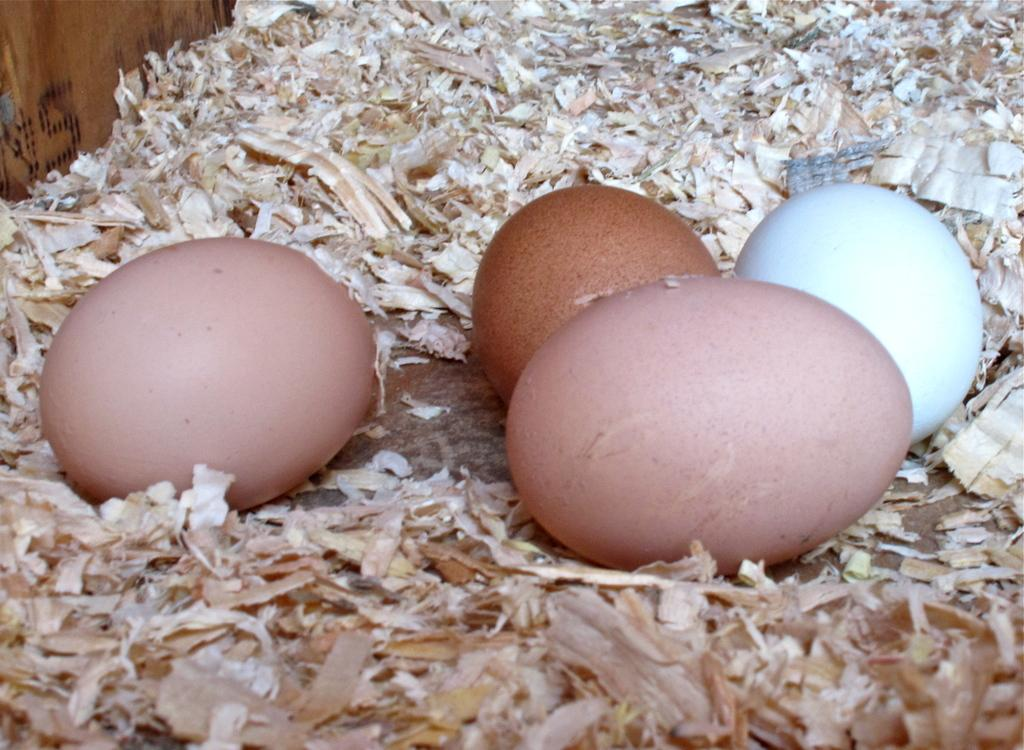What objects are placed on a surface in the image? There are eggs placed on a surface in the image. What is present around the eggs in the image? There is sawdust around the eggs in the image. What type of material is the board with text made of in the image? The wooden board with text is made of wood. What type of apparel is hanging on the door in the image? There is no door or apparel present in the image. How many buckets are visible in the image? There are no buckets visible in the image. 